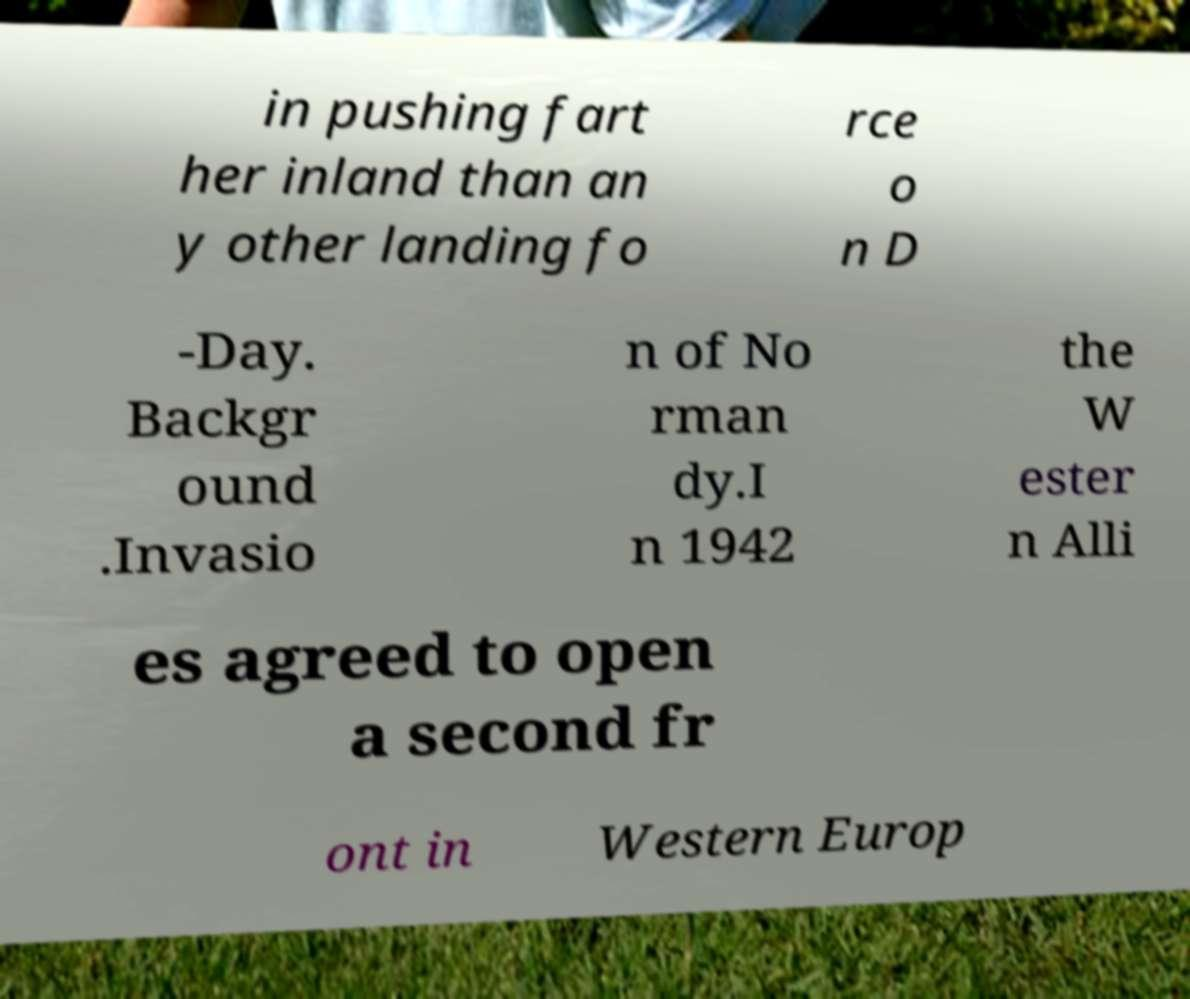Please read and relay the text visible in this image. What does it say? in pushing fart her inland than an y other landing fo rce o n D -Day. Backgr ound .Invasio n of No rman dy.I n 1942 the W ester n Alli es agreed to open a second fr ont in Western Europ 